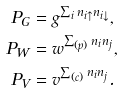<formula> <loc_0><loc_0><loc_500><loc_500>P _ { G } & = g ^ { \sum _ { i } n _ { i \uparrow } n _ { i \downarrow } } , \\ P _ { W } & = w ^ { \sum _ { ( p ) } n _ { i } n _ { j } } , \\ P _ { V } & = v ^ { \sum _ { ( c ) } n _ { i } n _ { j } } .</formula> 